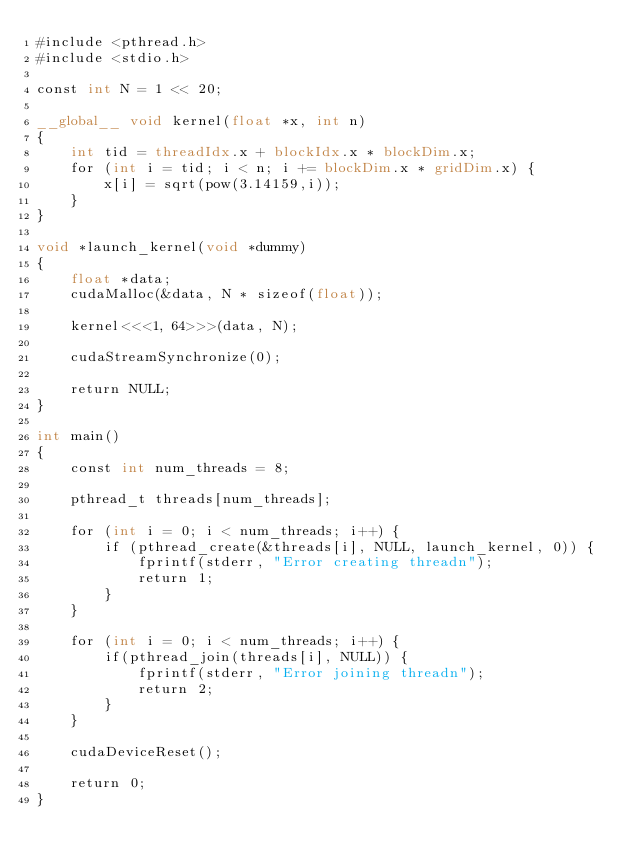Convert code to text. <code><loc_0><loc_0><loc_500><loc_500><_Cuda_>#include <pthread.h>
#include <stdio.h>

const int N = 1 << 20;

__global__ void kernel(float *x, int n)
{
    int tid = threadIdx.x + blockIdx.x * blockDim.x;
    for (int i = tid; i < n; i += blockDim.x * gridDim.x) {
        x[i] = sqrt(pow(3.14159,i));
    }
}

void *launch_kernel(void *dummy)
{
    float *data;
    cudaMalloc(&data, N * sizeof(float));

    kernel<<<1, 64>>>(data, N);

    cudaStreamSynchronize(0);

    return NULL;
}

int main()
{
    const int num_threads = 8;

    pthread_t threads[num_threads];

    for (int i = 0; i < num_threads; i++) {
        if (pthread_create(&threads[i], NULL, launch_kernel, 0)) {
            fprintf(stderr, "Error creating threadn");
            return 1;
        }
    }

    for (int i = 0; i < num_threads; i++) {
        if(pthread_join(threads[i], NULL)) {
            fprintf(stderr, "Error joining threadn");
            return 2;
        }
    }

    cudaDeviceReset();

    return 0;
}
</code> 